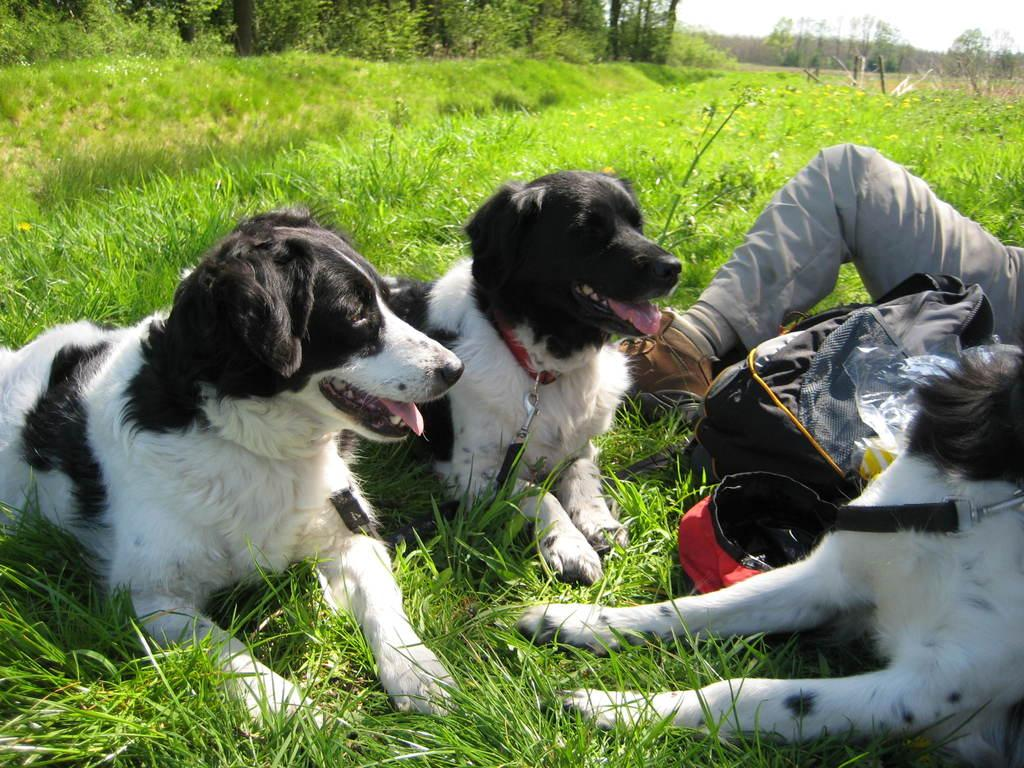How many dogs are present in the image? There are three dogs in the image. What else can be seen in the image besides the dogs? There is a bag, a person's leg, grass, plants, and trees visible in the image. What is the background of the image? The background of the image includes trees and the sky. What type of steam is coming out of the hydrant in the image? There is no hydrant present in the image, so there is no steam to be observed. 